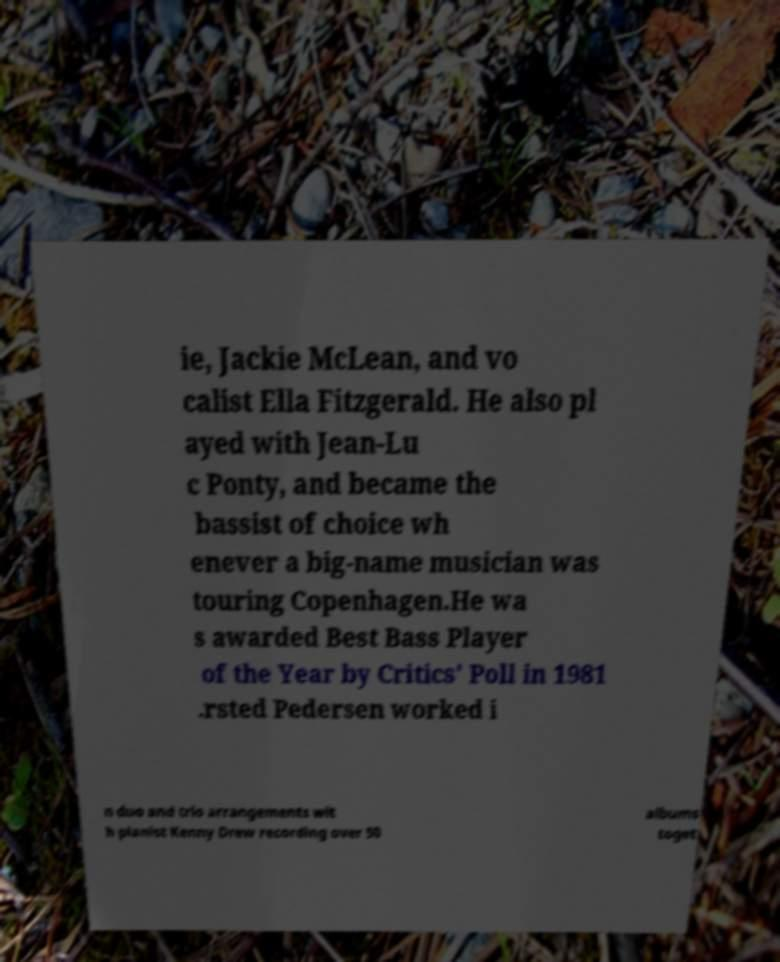Could you assist in decoding the text presented in this image and type it out clearly? ie, Jackie McLean, and vo calist Ella Fitzgerald. He also pl ayed with Jean-Lu c Ponty, and became the bassist of choice wh enever a big-name musician was touring Copenhagen.He wa s awarded Best Bass Player of the Year by Critics' Poll in 1981 .rsted Pedersen worked i n duo and trio arrangements wit h pianist Kenny Drew recording over 50 albums toget 